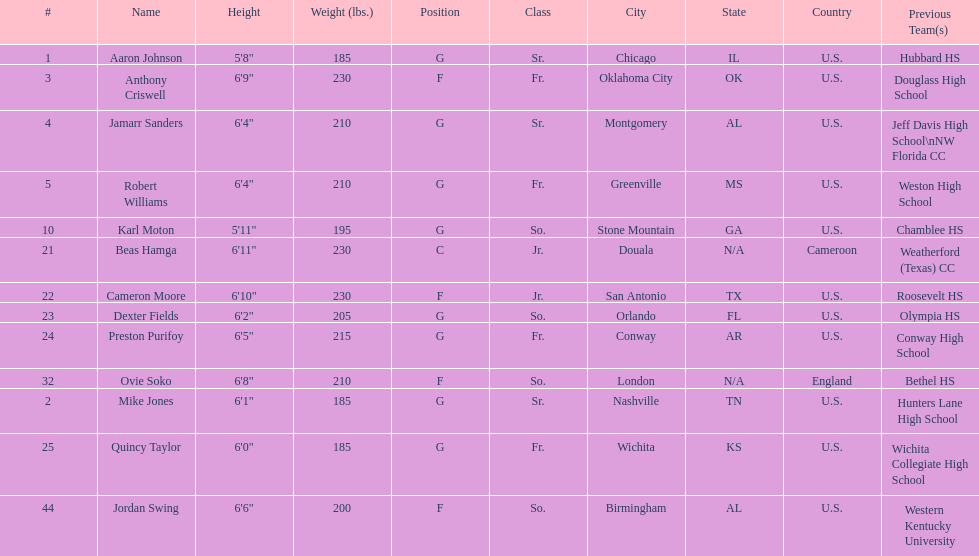Who weighs more, dexter fields or ovie soko? Ovie Soko. 